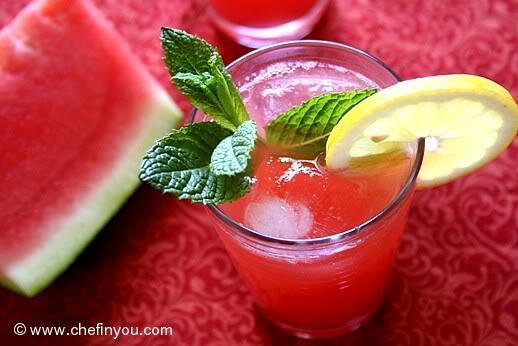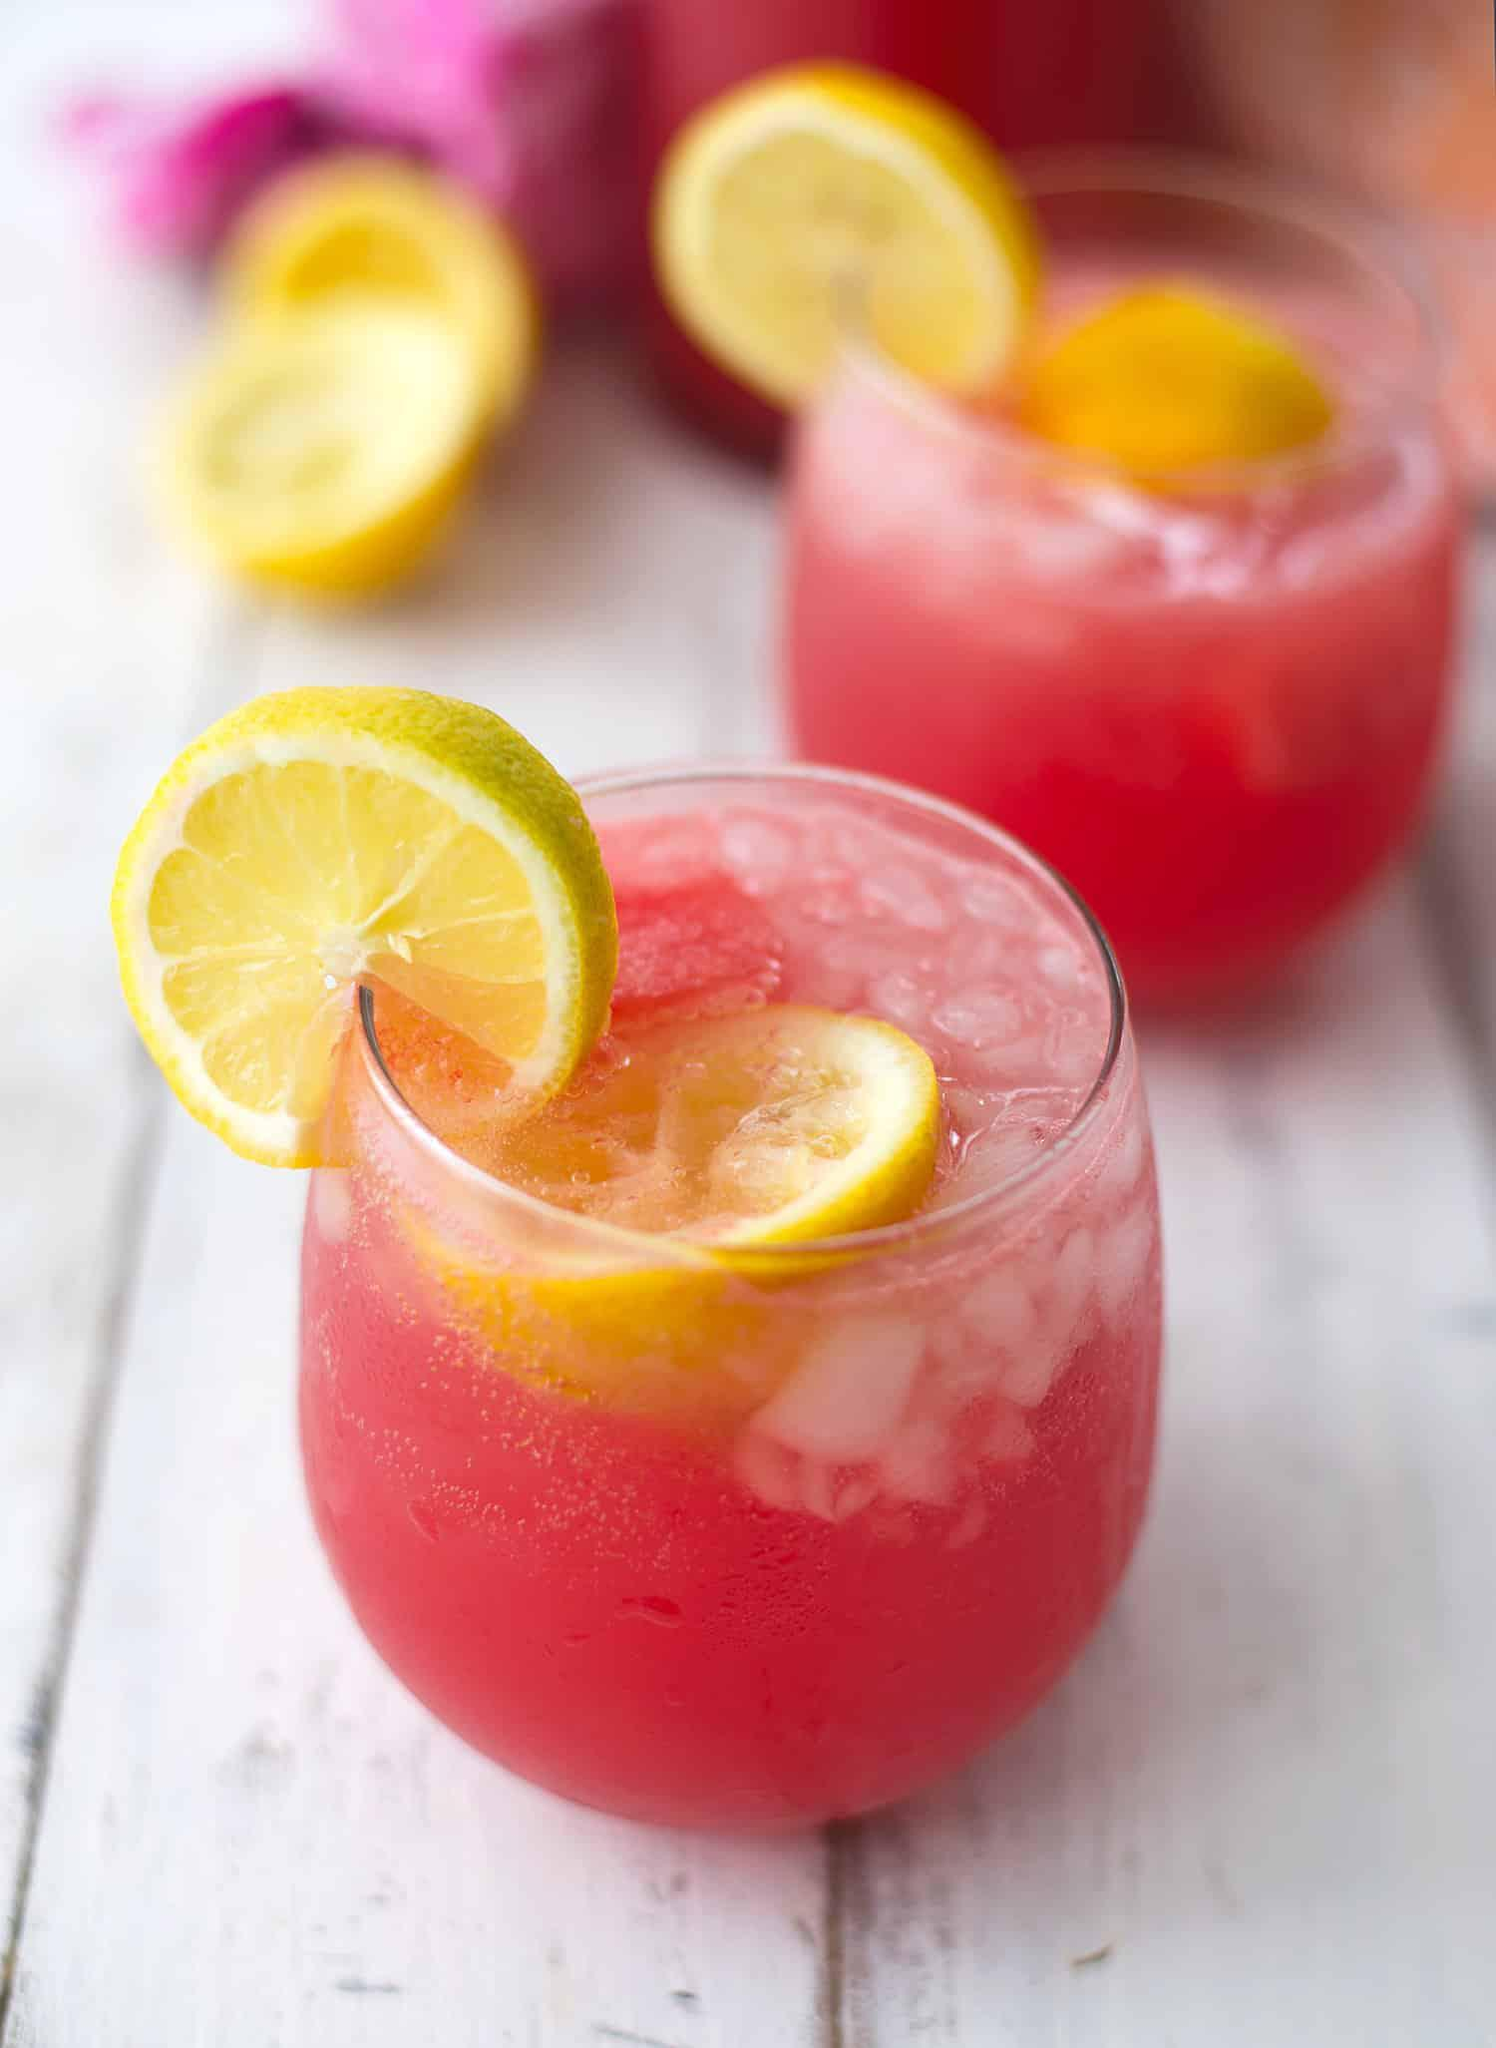The first image is the image on the left, the second image is the image on the right. For the images shown, is this caption "Left image shows glasses garnished with a thin watermelon slice." true? Answer yes or no. No. The first image is the image on the left, the second image is the image on the right. For the images shown, is this caption "All drink servings are garnished with striped straws." true? Answer yes or no. No. 